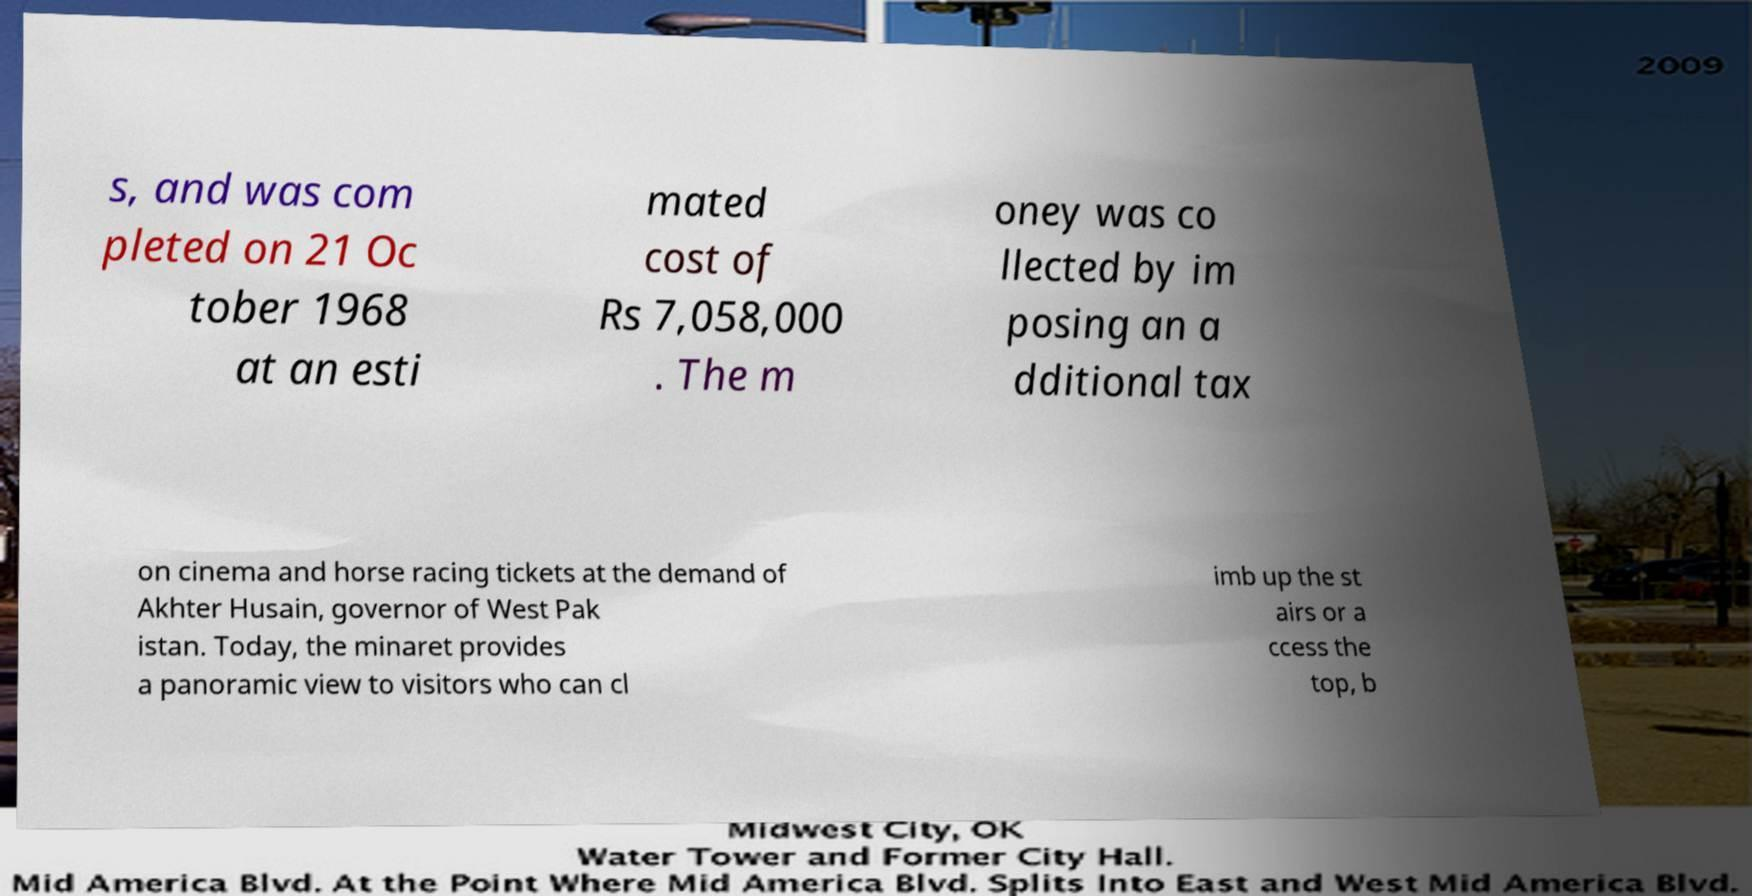Can you read and provide the text displayed in the image?This photo seems to have some interesting text. Can you extract and type it out for me? s, and was com pleted on 21 Oc tober 1968 at an esti mated cost of Rs 7,058,000 . The m oney was co llected by im posing an a dditional tax on cinema and horse racing tickets at the demand of Akhter Husain, governor of West Pak istan. Today, the minaret provides a panoramic view to visitors who can cl imb up the st airs or a ccess the top, b 